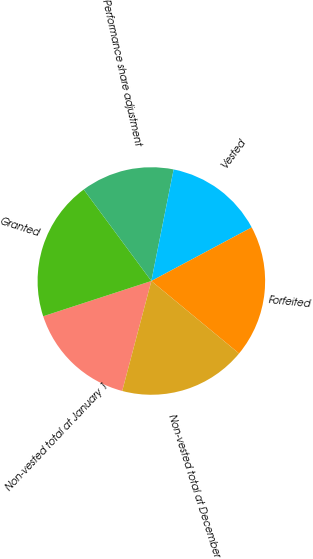<chart> <loc_0><loc_0><loc_500><loc_500><pie_chart><fcel>Non-vested total at January 1<fcel>Granted<fcel>Performance share adjustment<fcel>Vested<fcel>Forfeited<fcel>Non-vested total at December<nl><fcel>15.86%<fcel>19.88%<fcel>13.27%<fcel>14.05%<fcel>18.8%<fcel>18.13%<nl></chart> 